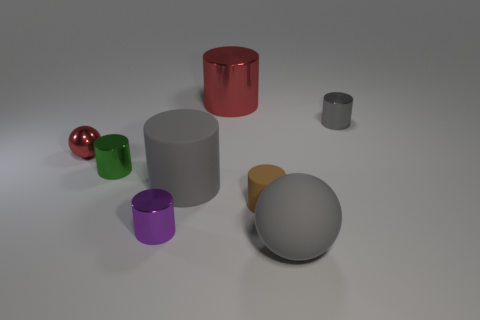Are there more brown matte things than tiny red cylinders?
Offer a terse response. Yes. The tiny object that is on the right side of the big gray thing that is in front of the metal cylinder that is in front of the tiny green cylinder is what color?
Ensure brevity in your answer.  Gray. Do the metal thing that is on the right side of the gray sphere and the tiny red metallic thing have the same shape?
Your response must be concise. No. There is a sphere that is the same size as the red cylinder; what color is it?
Offer a very short reply. Gray. What number of gray balls are there?
Offer a very short reply. 1. Is the cylinder in front of the tiny brown cylinder made of the same material as the large red cylinder?
Your answer should be compact. Yes. There is a thing that is both behind the rubber sphere and on the right side of the brown object; what material is it?
Provide a succinct answer. Metal. The metallic cylinder that is the same color as the small ball is what size?
Keep it short and to the point. Large. What is the object behind the gray object behind the big gray matte cylinder made of?
Ensure brevity in your answer.  Metal. How big is the red object to the right of the ball behind the large thing in front of the purple thing?
Offer a terse response. Large. 